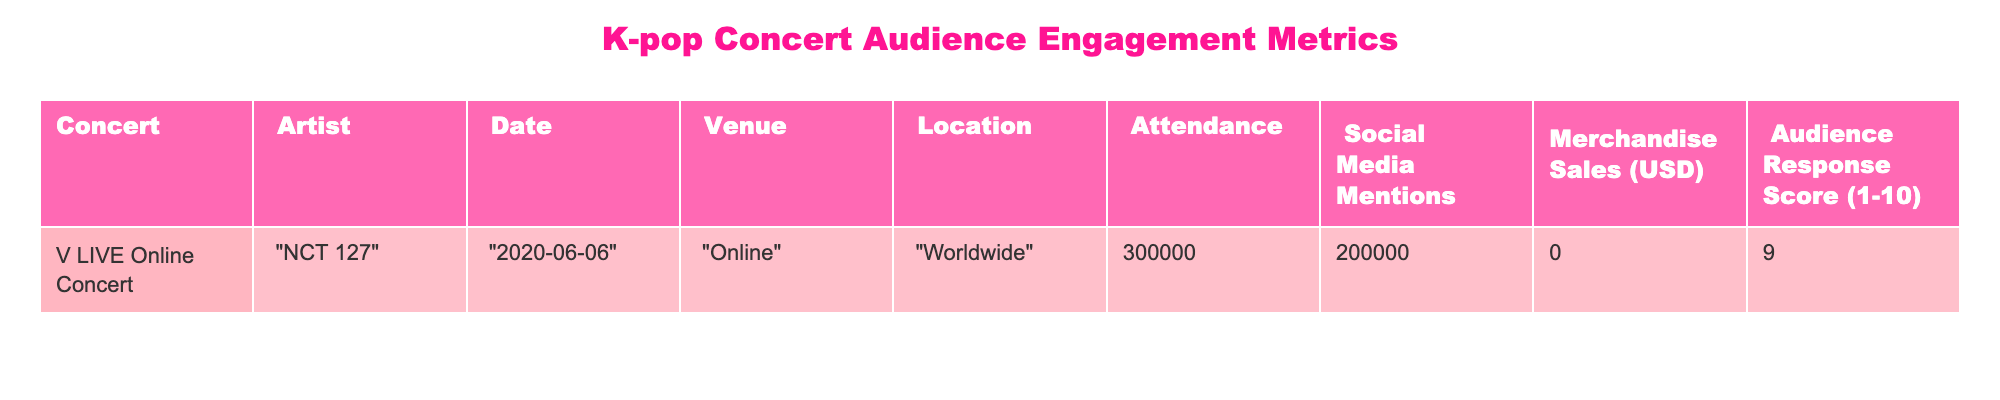What is the attendance for the NCT 127 V LIVE Online Concert? The table shows the "Attendance" column under the "V LIVE Online Concert" row where it lists "300000". Therefore, the attendance is confirmed to be this number.
Answer: 300000 What is the number of social media mentions for this concert? By referring to the "Social Media Mentions" column in the same row for the concert, it indicates "200000". This number represents the mentions on social media platforms during this event.
Answer: 200000 Is the merchandise sales amount for this concert greater than $100,000? Looking at the "Merchandise Sales" column for this concert, it shows "0", which means no merchandise sales occurred. Since 0 is not greater than 100,000, the answer to this is false.
Answer: No What is the audience response score for the NCT 127 concert? The "Audience Response Score" can be found in the same row which lists "9". This indicates the audience rated the concert highly on a scale of 1 to 10.
Answer: 9 What is the total attendance and social media mentions for the concert combined? The attendance is "300000" and social media mentions are "200000". Adding these two values gives: 300000 + 200000 = 500000. This computation gives us the combined total for both metrics.
Answer: 500000 Is the venue for the concert online or in a physical location? In the "Venue" column of the table, it clearly states "Online", confirming that the concert did not take place at a physical venue but rather through an online platform.
Answer: Yes What is the ratio of social media mentions to attendance for the NCT 127 concert? To find the ratio, we divide the number of social media mentions (200000) by the attendance (300000). So, the ratio is 200000/300000, which simplifies to 2/3 or approximately 0.67 when calculated.
Answer: 0.67 Did the NCT 127 concert generate any merchandise sales? The "Merchandise Sales" for this concert in the table shows "0", which indicates that no sales were generated. Hence, the answer to whether they generated any sales is false.
Answer: No What date was the NCT 127 V LIVE Online Concert held? The date can be found in the column labeled "Date" in the concert row, which lists "2020-06-06". This clearly indicates when the concert took place.
Answer: 2020-06-06 